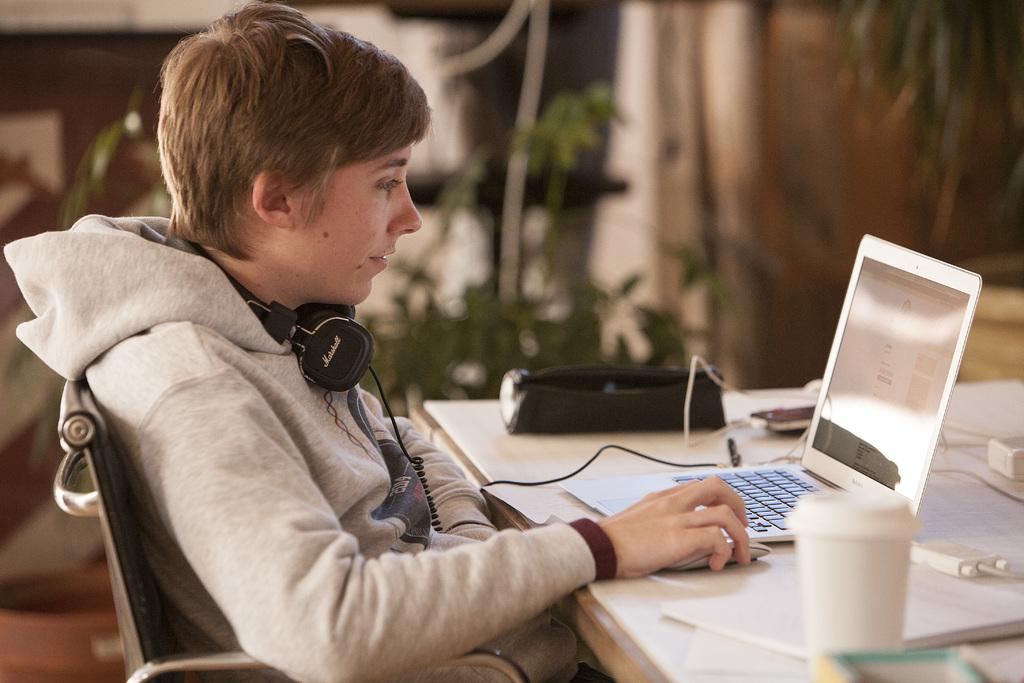What is the person in the image doing? The person is sitting on a chair in the image. What is the person wearing that is visible in the image? The person is wearing headphones. What is on the table in front of the person? There is a laptop and other objects on the table. What device is on the table that the person might be using? A laptop is present on the table. What can be seen in the background of the image? There is a tree visible in the image. What type of bread is being used to hold the glue in the image? There is no bread or glue present in the image. 